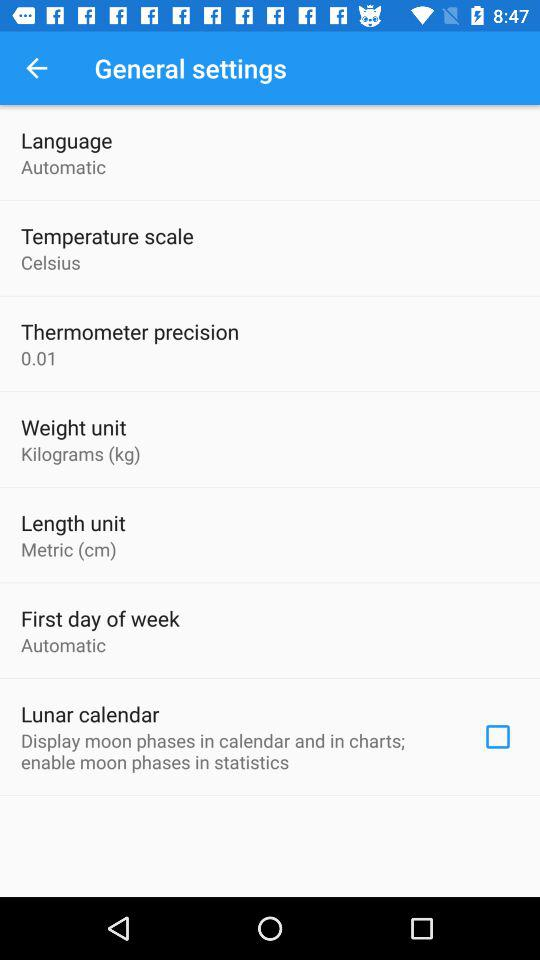What is thermometer precision? The thermometer precision is 0.01. 